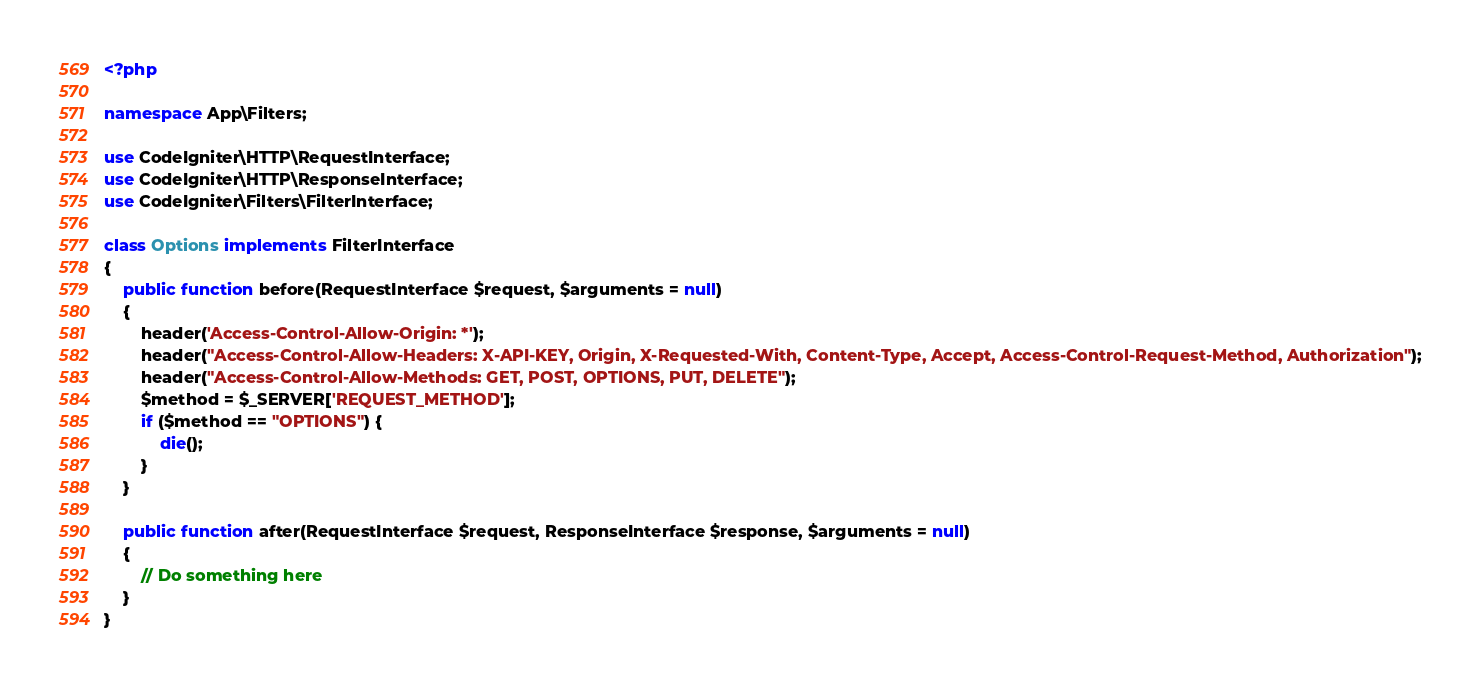<code> <loc_0><loc_0><loc_500><loc_500><_PHP_><?php

namespace App\Filters;

use CodeIgniter\HTTP\RequestInterface;
use CodeIgniter\HTTP\ResponseInterface;
use CodeIgniter\Filters\FilterInterface;

class Options implements FilterInterface
{
    public function before(RequestInterface $request, $arguments = null)
    {
        header('Access-Control-Allow-Origin: *');
        header("Access-Control-Allow-Headers: X-API-KEY, Origin, X-Requested-With, Content-Type, Accept, Access-Control-Request-Method, Authorization");
        header("Access-Control-Allow-Methods: GET, POST, OPTIONS, PUT, DELETE");
        $method = $_SERVER['REQUEST_METHOD'];
        if ($method == "OPTIONS") {
            die();
        }
    }

    public function after(RequestInterface $request, ResponseInterface $response, $arguments = null)
    {
        // Do something here
    }
}
</code> 